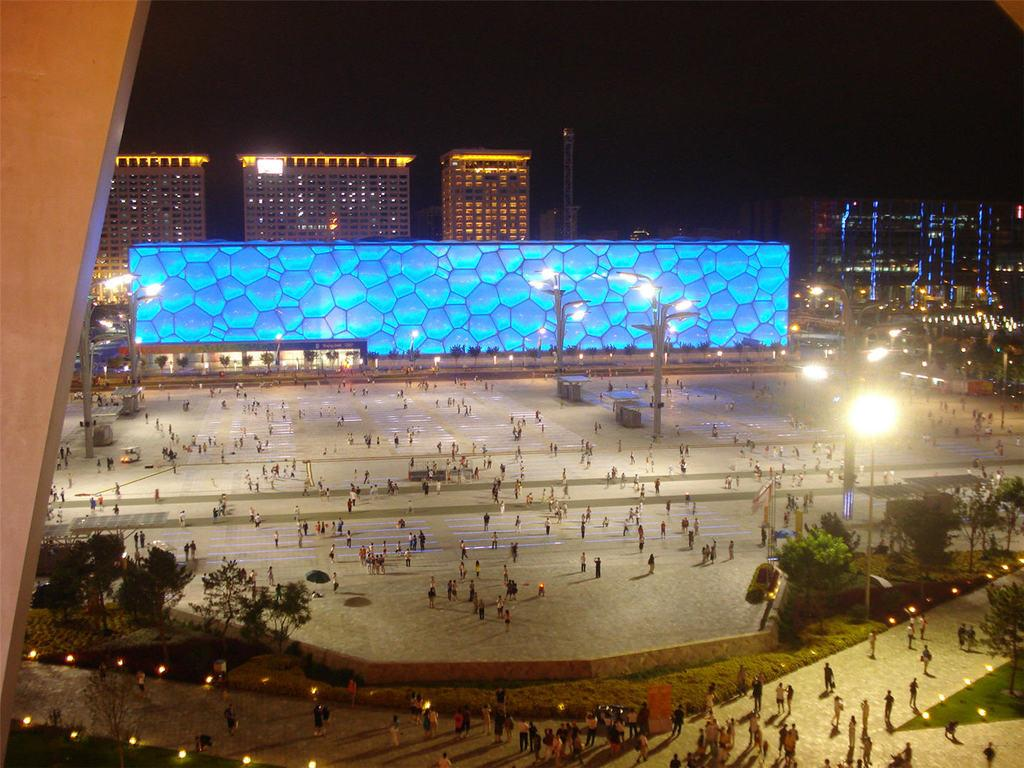Who or what is present in the image? There are people in the image. What structures can be seen in the image? There are poles, lights, tables, trees, buildings, and a tower in the image. What is the background of the image like? The background of the image is dark. What type of foot treatment is being performed in the image? There is no foot treatment being performed in the image; it does not depict any medical procedures or treatments. 